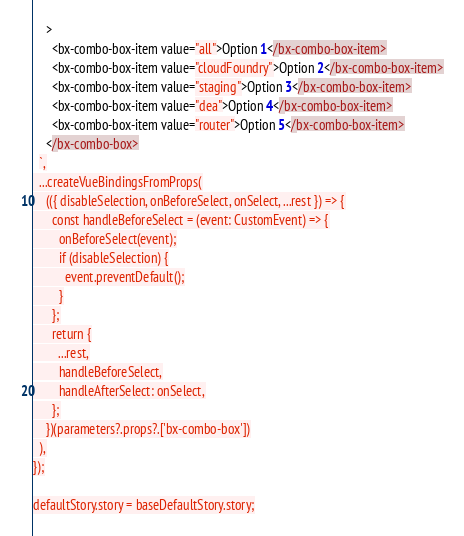Convert code to text. <code><loc_0><loc_0><loc_500><loc_500><_TypeScript_>    >
      <bx-combo-box-item value="all">Option 1</bx-combo-box-item>
      <bx-combo-box-item value="cloudFoundry">Option 2</bx-combo-box-item>
      <bx-combo-box-item value="staging">Option 3</bx-combo-box-item>
      <bx-combo-box-item value="dea">Option 4</bx-combo-box-item>
      <bx-combo-box-item value="router">Option 5</bx-combo-box-item>
    </bx-combo-box>
  `,
  ...createVueBindingsFromProps(
    (({ disableSelection, onBeforeSelect, onSelect, ...rest }) => {
      const handleBeforeSelect = (event: CustomEvent) => {
        onBeforeSelect(event);
        if (disableSelection) {
          event.preventDefault();
        }
      };
      return {
        ...rest,
        handleBeforeSelect,
        handleAfterSelect: onSelect,
      };
    })(parameters?.props?.['bx-combo-box'])
  ),
});

defaultStory.story = baseDefaultStory.story;
</code> 